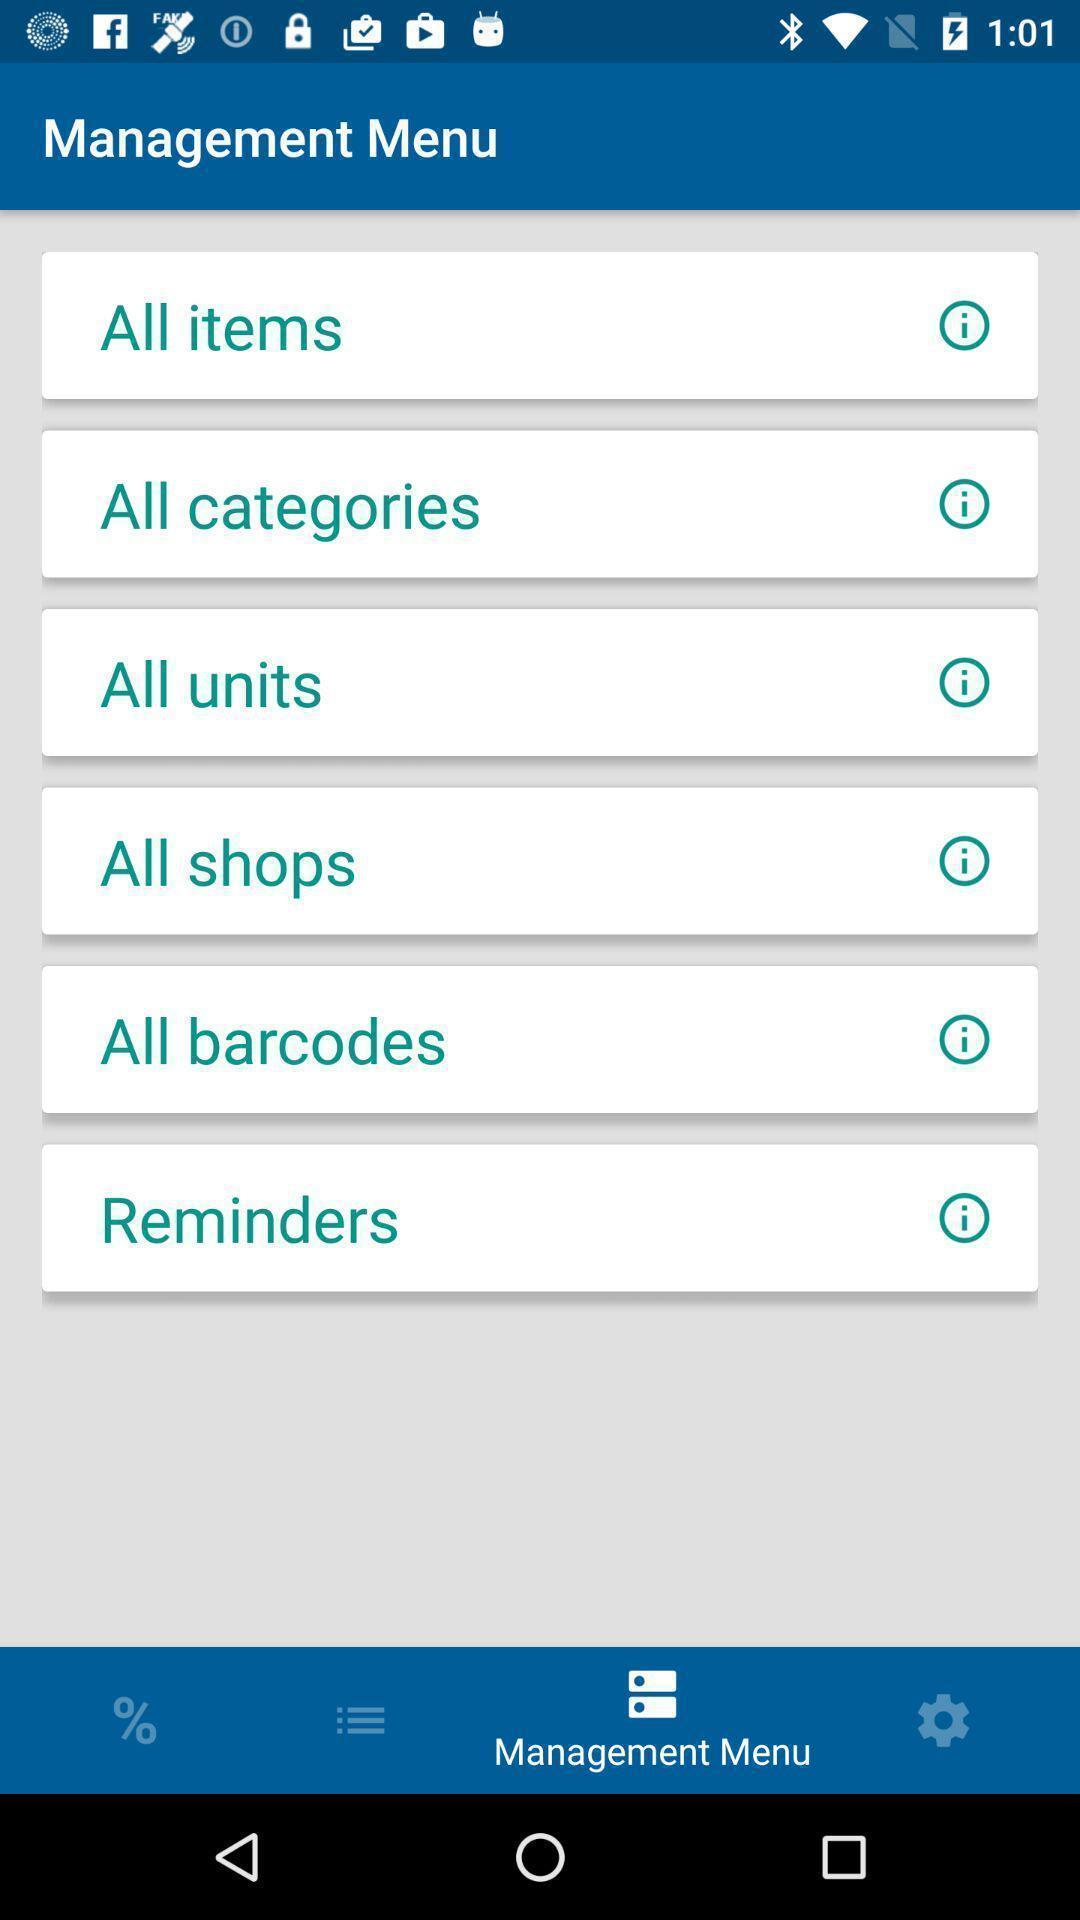Summarize the information in this screenshot. Page showing different options for managing your menu. 